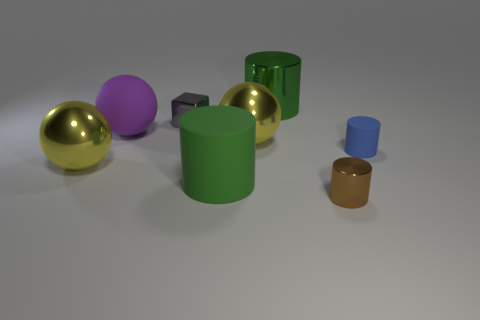Subtract all large green shiny cylinders. How many cylinders are left? 3 Add 2 small metal spheres. How many objects exist? 10 Subtract all blue cylinders. How many cylinders are left? 3 Subtract all blocks. How many objects are left? 7 Subtract all gray balls. How many green cylinders are left? 2 Subtract 3 cylinders. How many cylinders are left? 1 Add 4 tiny things. How many tiny things are left? 7 Add 5 big gray rubber balls. How many big gray rubber balls exist? 5 Subtract 0 blue blocks. How many objects are left? 8 Subtract all brown cylinders. Subtract all red balls. How many cylinders are left? 3 